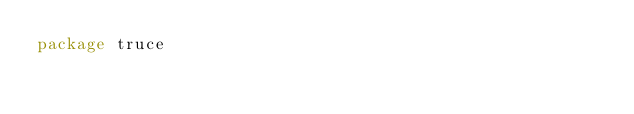Convert code to text. <code><loc_0><loc_0><loc_500><loc_500><_Go_>package truce
</code> 